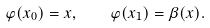<formula> <loc_0><loc_0><loc_500><loc_500>\varphi ( x _ { 0 } ) = x , \quad \varphi ( x _ { 1 } ) = \beta ( x ) .</formula> 